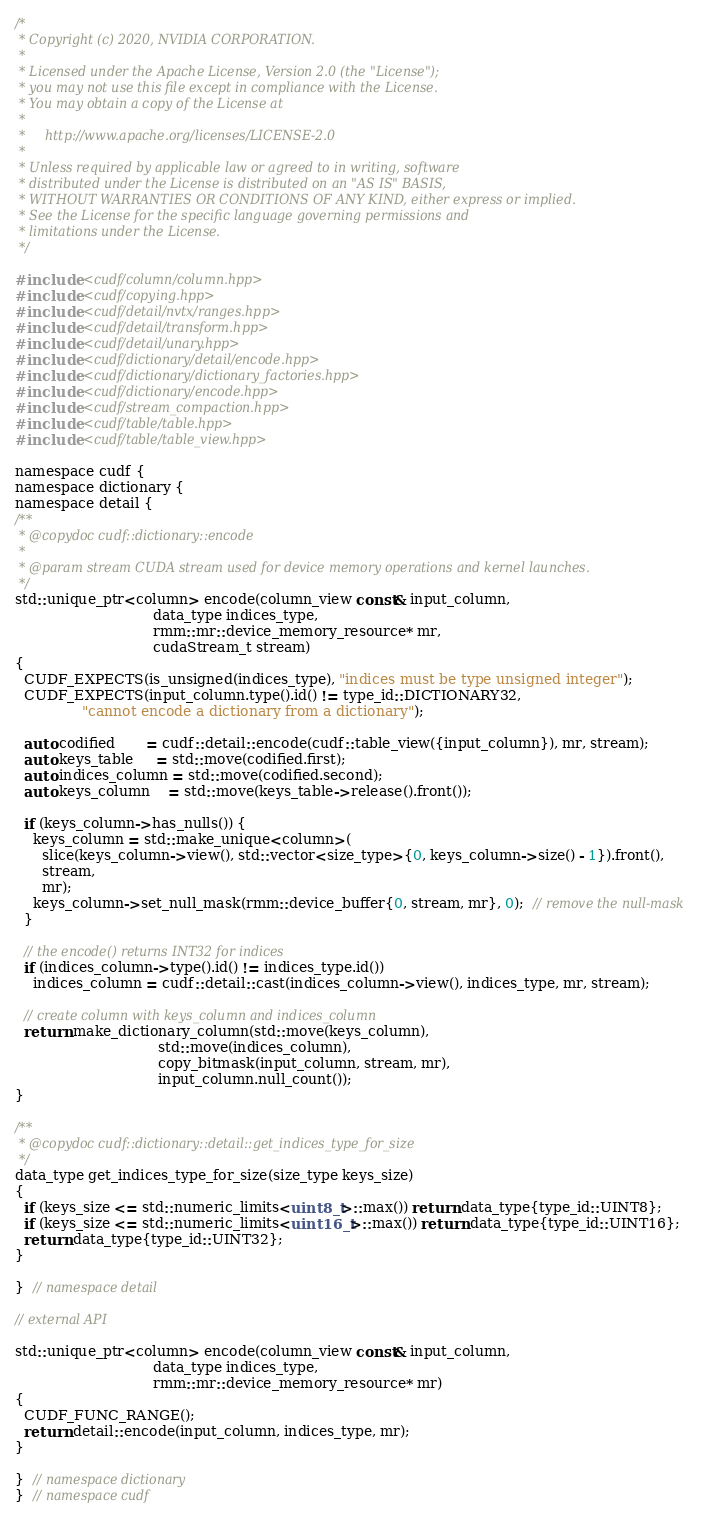<code> <loc_0><loc_0><loc_500><loc_500><_Cuda_>/*
 * Copyright (c) 2020, NVIDIA CORPORATION.
 *
 * Licensed under the Apache License, Version 2.0 (the "License");
 * you may not use this file except in compliance with the License.
 * You may obtain a copy of the License at
 *
 *     http://www.apache.org/licenses/LICENSE-2.0
 *
 * Unless required by applicable law or agreed to in writing, software
 * distributed under the License is distributed on an "AS IS" BASIS,
 * WITHOUT WARRANTIES OR CONDITIONS OF ANY KIND, either express or implied.
 * See the License for the specific language governing permissions and
 * limitations under the License.
 */

#include <cudf/column/column.hpp>
#include <cudf/copying.hpp>
#include <cudf/detail/nvtx/ranges.hpp>
#include <cudf/detail/transform.hpp>
#include <cudf/detail/unary.hpp>
#include <cudf/dictionary/detail/encode.hpp>
#include <cudf/dictionary/dictionary_factories.hpp>
#include <cudf/dictionary/encode.hpp>
#include <cudf/stream_compaction.hpp>
#include <cudf/table/table.hpp>
#include <cudf/table/table_view.hpp>

namespace cudf {
namespace dictionary {
namespace detail {
/**
 * @copydoc cudf::dictionary::encode
 *
 * @param stream CUDA stream used for device memory operations and kernel launches.
 */
std::unique_ptr<column> encode(column_view const& input_column,
                               data_type indices_type,
                               rmm::mr::device_memory_resource* mr,
                               cudaStream_t stream)
{
  CUDF_EXPECTS(is_unsigned(indices_type), "indices must be type unsigned integer");
  CUDF_EXPECTS(input_column.type().id() != type_id::DICTIONARY32,
               "cannot encode a dictionary from a dictionary");

  auto codified       = cudf::detail::encode(cudf::table_view({input_column}), mr, stream);
  auto keys_table     = std::move(codified.first);
  auto indices_column = std::move(codified.second);
  auto keys_column    = std::move(keys_table->release().front());

  if (keys_column->has_nulls()) {
    keys_column = std::make_unique<column>(
      slice(keys_column->view(), std::vector<size_type>{0, keys_column->size() - 1}).front(),
      stream,
      mr);
    keys_column->set_null_mask(rmm::device_buffer{0, stream, mr}, 0);  // remove the null-mask
  }

  // the encode() returns INT32 for indices
  if (indices_column->type().id() != indices_type.id())
    indices_column = cudf::detail::cast(indices_column->view(), indices_type, mr, stream);

  // create column with keys_column and indices_column
  return make_dictionary_column(std::move(keys_column),
                                std::move(indices_column),
                                copy_bitmask(input_column, stream, mr),
                                input_column.null_count());
}

/**
 * @copydoc cudf::dictionary::detail::get_indices_type_for_size
 */
data_type get_indices_type_for_size(size_type keys_size)
{
  if (keys_size <= std::numeric_limits<uint8_t>::max()) return data_type{type_id::UINT8};
  if (keys_size <= std::numeric_limits<uint16_t>::max()) return data_type{type_id::UINT16};
  return data_type{type_id::UINT32};
}

}  // namespace detail

// external API

std::unique_ptr<column> encode(column_view const& input_column,
                               data_type indices_type,
                               rmm::mr::device_memory_resource* mr)
{
  CUDF_FUNC_RANGE();
  return detail::encode(input_column, indices_type, mr);
}

}  // namespace dictionary
}  // namespace cudf
</code> 